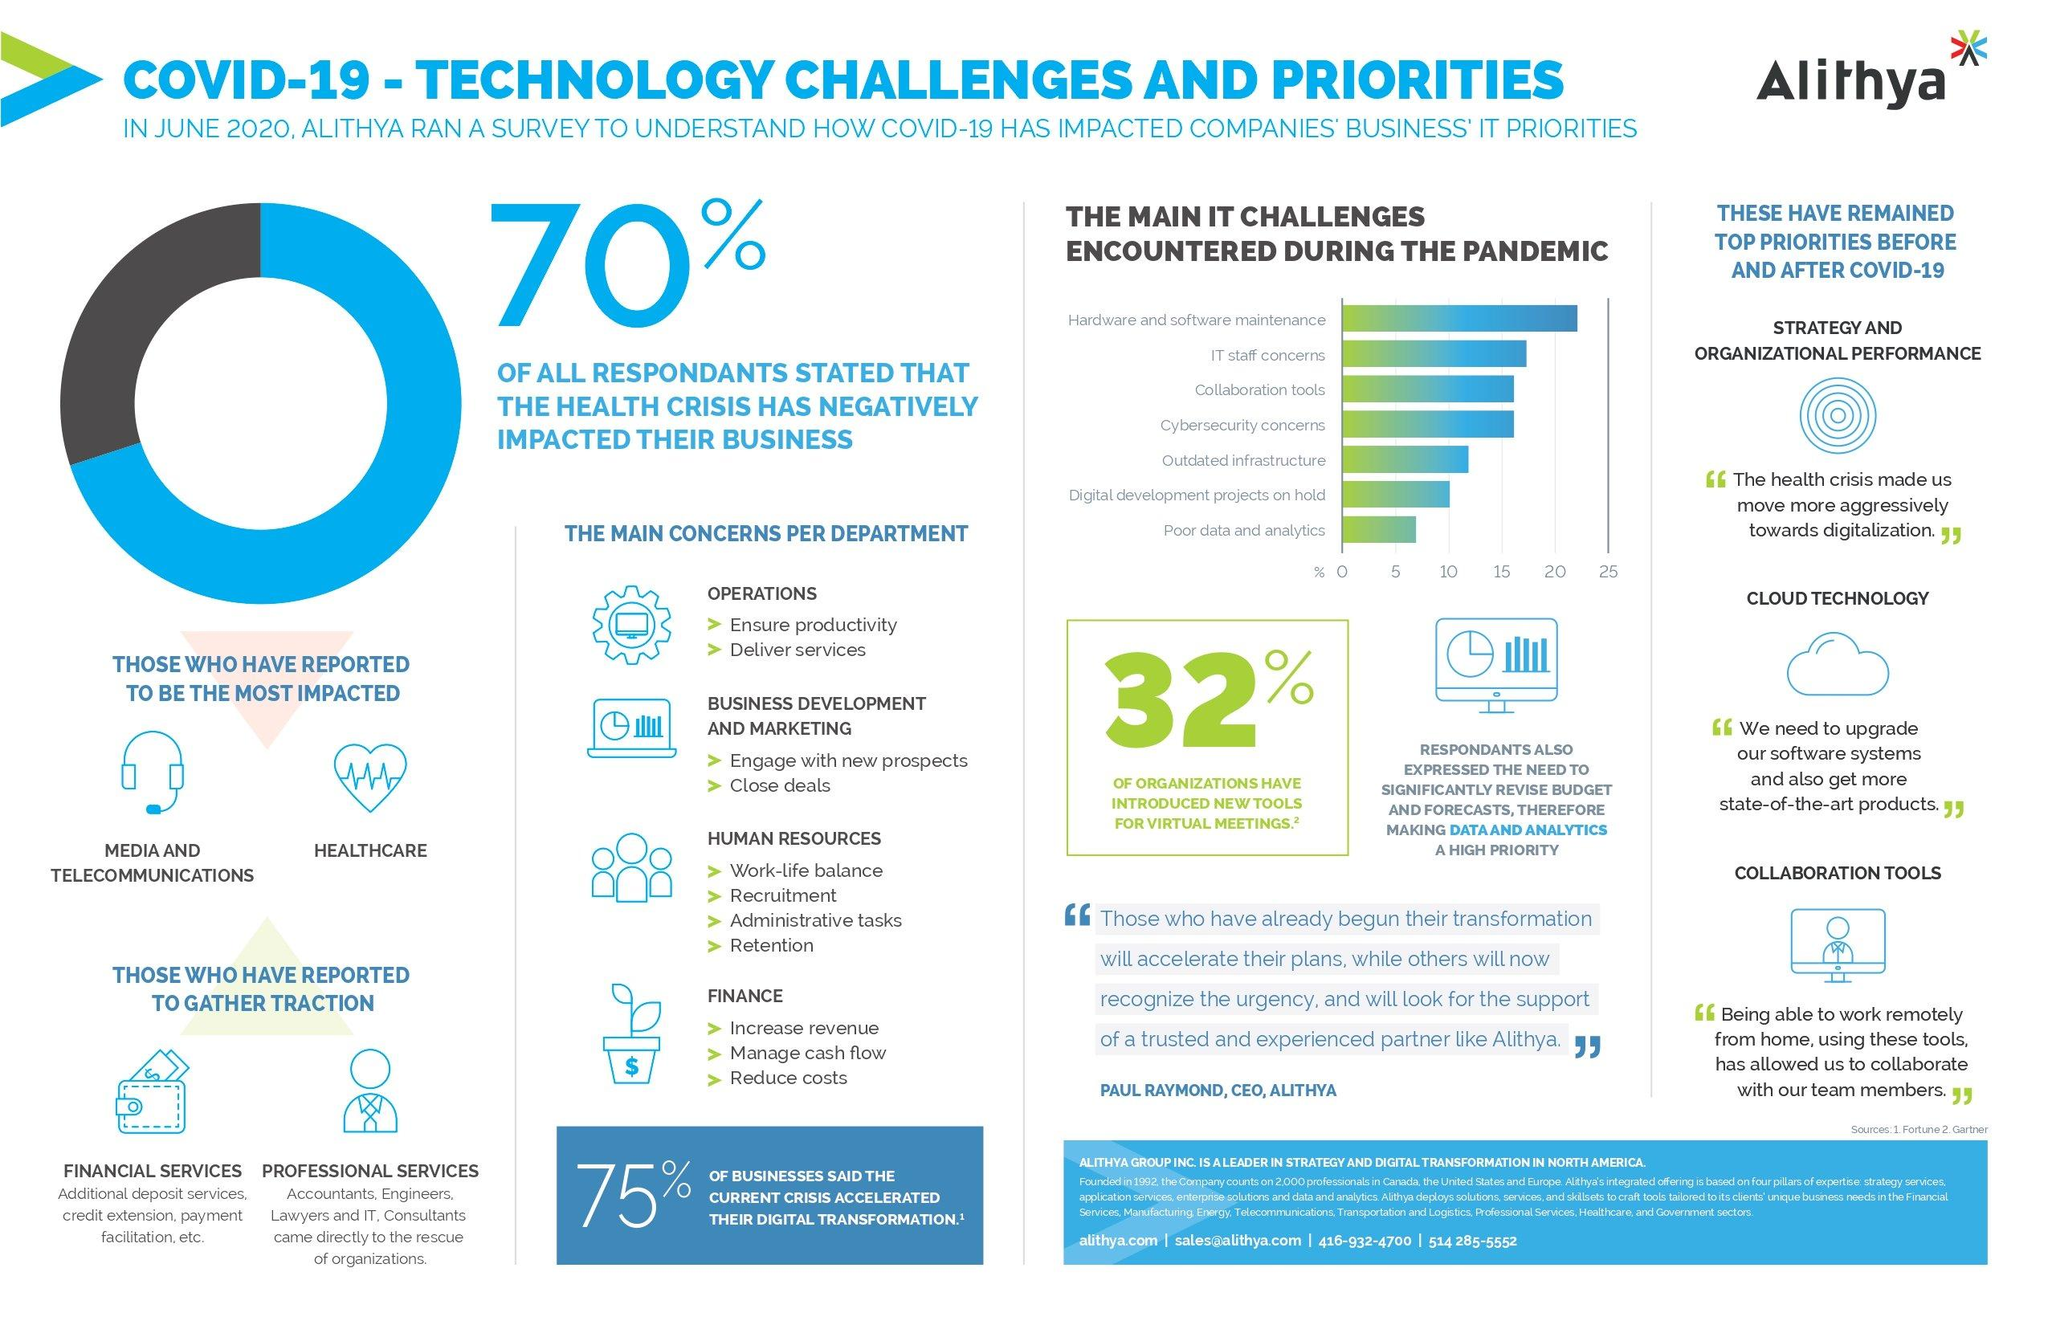List a handful of essential elements in this visual. During the pandemic, a survey revealed that 20% of the IT challenges encountered were related to hardware and software maintenance. According to the survey results, approximately 30% of respondents were not negatively impacted by the health crisis. 